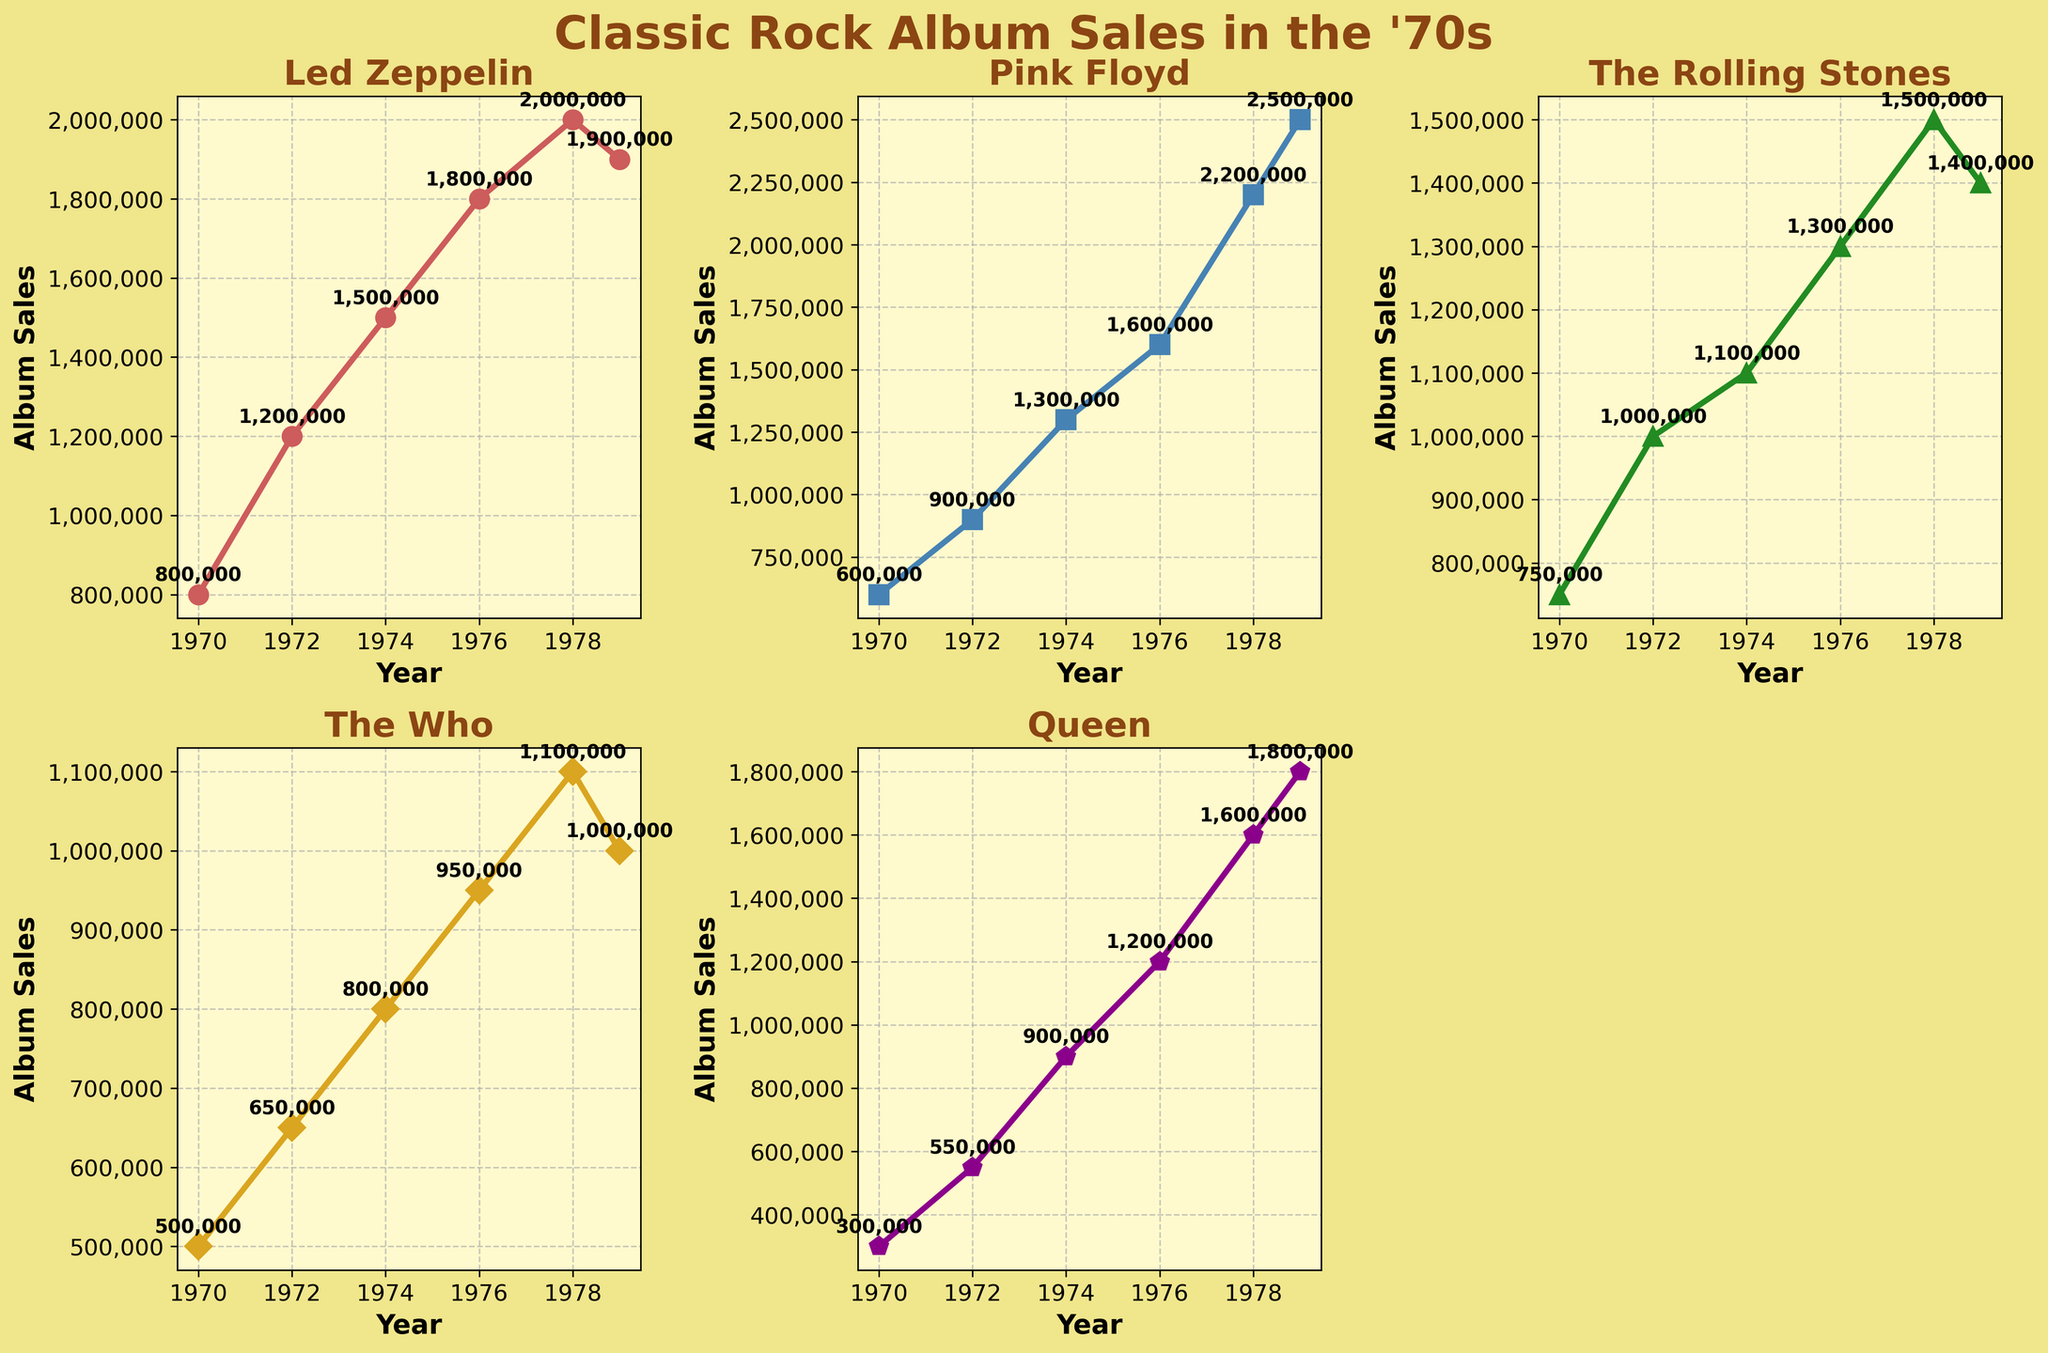What is the title of the figure? The title is typically located at the top center of the figure; in this case, the code specifies it.
Answer: Classic Rock Album Sales in the '70s Which artist had the highest album sales in 1979? By examining the markers at the 1979 data point, you can see that Pink Floyd had the highest sales among the artists listed.
Answer: Pink Floyd How do the sales of Led Zeppelin compare from 1970 to 1978? Look at the data points for Led Zeppelin in 1970 and 1978; it increased from 800,000 to 2,000,000.
Answer: Increased by 1,200,000 In which year did The Rolling Stones have the highest sales among the given years, and what was the sales figure? The sales for The Rolling Stones peaked in 1978 as seen by the highest marker point for this artist's line.
Answer: 1978, 1,500,000 Who had the lowest album sales in 1978? Look at the markers for all artists in 1978 to see that The Who had the lowest sales at that point.
Answer: The Who What is the total album sales for Queen over the given years? Sum the sales values for Queen: 300,000 + 550,000 + 900,000 + 1,200,000 + 1,600,000 + 1,800,000 = 6,350,000
Answer: 6,350,000 Compare the trend of album sales for The Who and Led Zeppelin from 1974 to 1979. Observe the slopes of their lines: both have a general upward trend, but Led Zeppelin remains consistently higher. The Who shows smaller increases over time.
Answer: The Who had a smaller increase compared to Led Zeppelin Between 1976 and 1978, which artist saw the greatest increase in album sales? Compare the differences between 1976 and 1978 figures for all artists; Pink Floyd went from 1,600,000 to 2,200,000, the largest increase of 600,000.
Answer: Pink Floyd What was the average album sales of The Who from 1970 to 1979? Average is calculated by summing The Who's sales and dividing by the number of years: (500,000 + 650,000 + 800,000 + 950,000 + 1,100,000 + 1,000,000) / 6 = 833,333.33
Answer: 833,333.33 